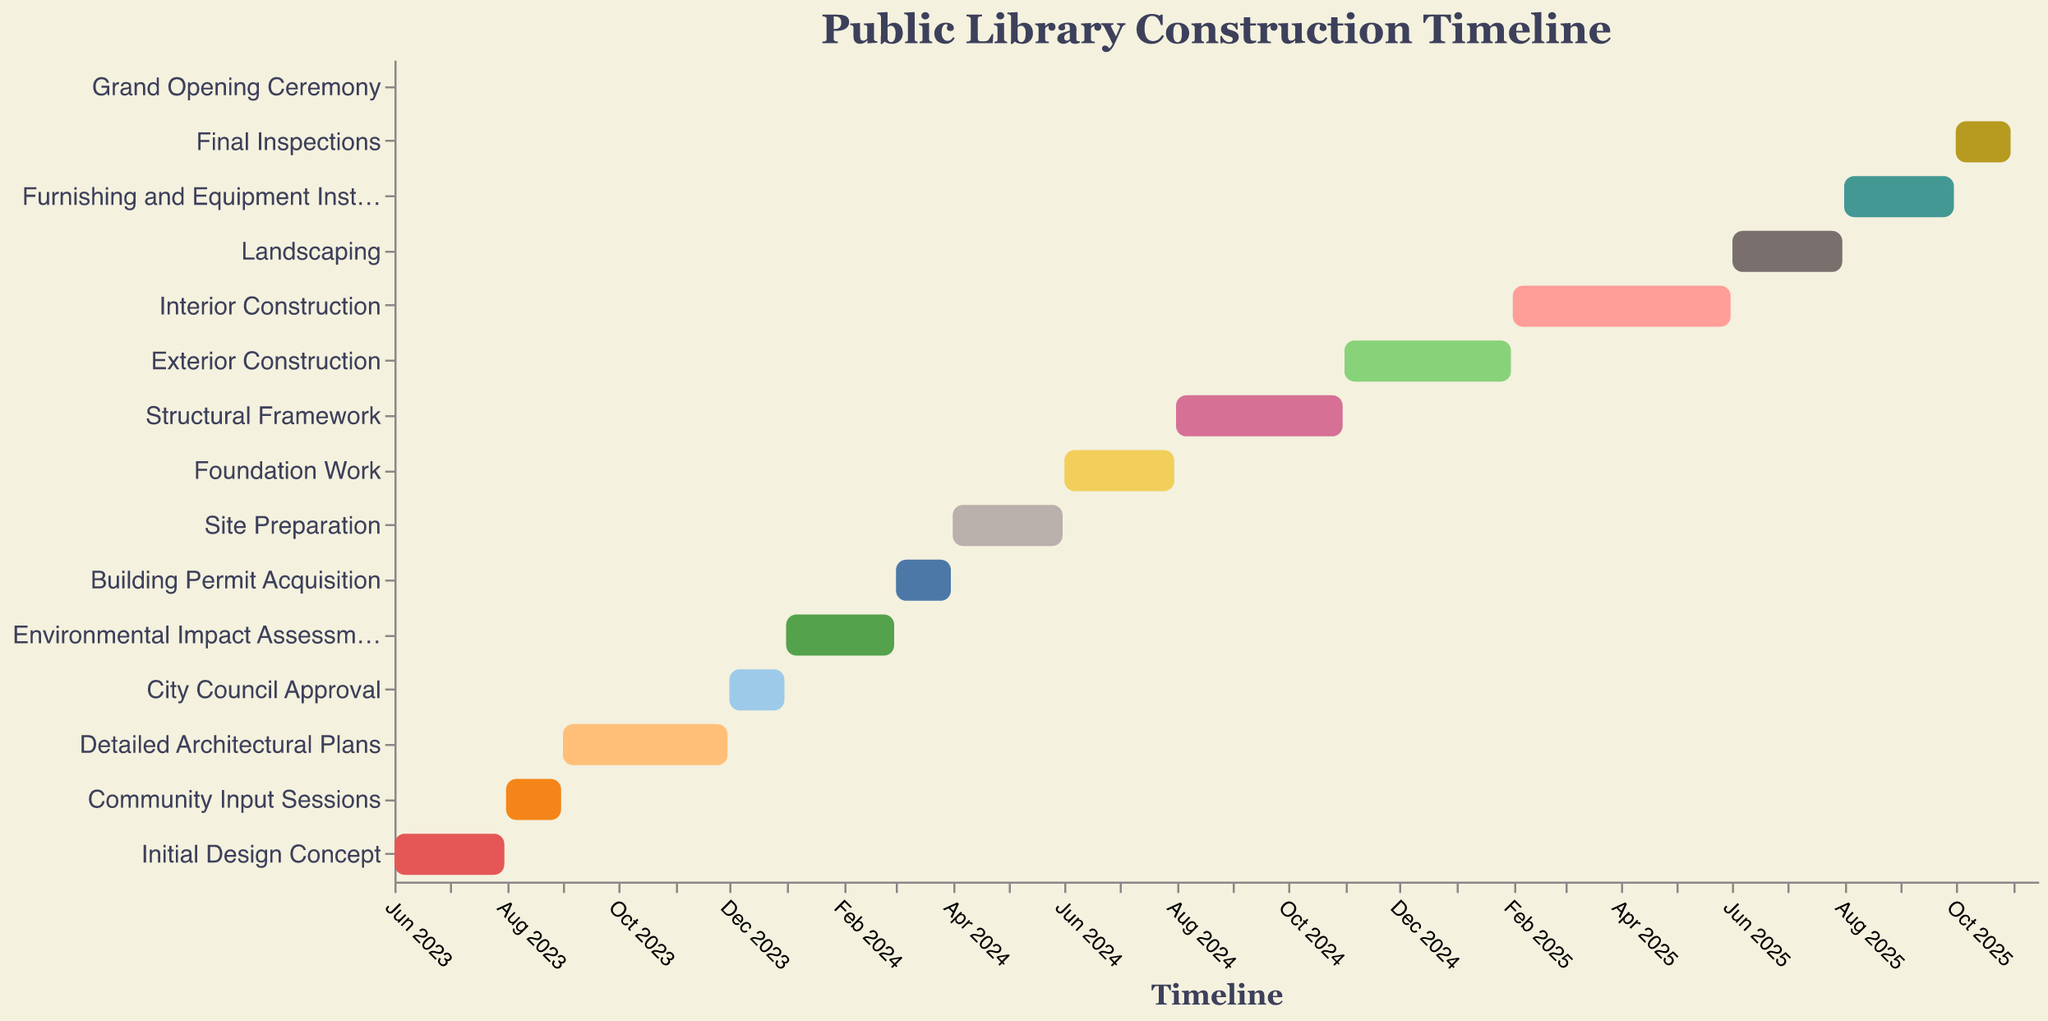When does the Initial Design Concept start and end? The Initial Design Concept starts on June 1, 2023, and ends on July 31, 2023, as indicated on the Gantt chart.
Answer: June 1, 2023, to July 31, 2023 What is the duration of the Detailed Architectural Plans? The Detailed Architectural Plans task starts on September 1, 2023, and ends on November 30, 2023. The duration is therefore the time between these two dates.
Answer: 3 months Which task immediately follows the Community Input Sessions? Following the Community Input Sessions, the next task is the Detailed Architectural Plans, as shown by the sequence in the Gantt chart.
Answer: Detailed Architectural Plans What is the total duration from the start of Environmental Impact Assessment to the end of Building Permit Acquisition? The Environmental Impact Assessment starts on January 1, 2024, and ends on February 29, 2024. The Building Permit Acquisition starts on March 1, 2024, and ends on March 31, 2024. Adding up both durations gives 2 months for the Environmental Impact Assessment and 1 month for the Building Permit Acquisition.
Answer: 3 months How do the durations of Site Preparation and Structural Framework compare? Site Preparation runs from April 1, 2024, to May 31, 2024, and Structural Framework runs from August 1, 2024, to October 31, 2024. Both tasks last for 2 months each, making their durations equal.
Answer: Equal Which tasks take place entirely within the year 2025? Tasks that start and end within 2025 are Interior Construction, Landscaping, Furnishing and Equipment Installation, Final Inspections, and the Grand Opening Ceremony.
Answer: Interior Construction, Landscaping, Furnishing and Equipment Installation, Final Inspections, Grand Opening Ceremony When is the Grand Opening Ceremony scheduled? The Grand Opening Ceremony is scheduled for November 15, 2025, as indicated by the concise date listed on the Gantt chart.
Answer: November 15, 2025 What stages of construction take place after Site Preparation but before Interior Construction? The stages of construction that fall within this timeframe include Foundation Work, Structural Framework, and Exterior Construction.
Answer: Foundation Work, Structural Framework, Exterior Construction 